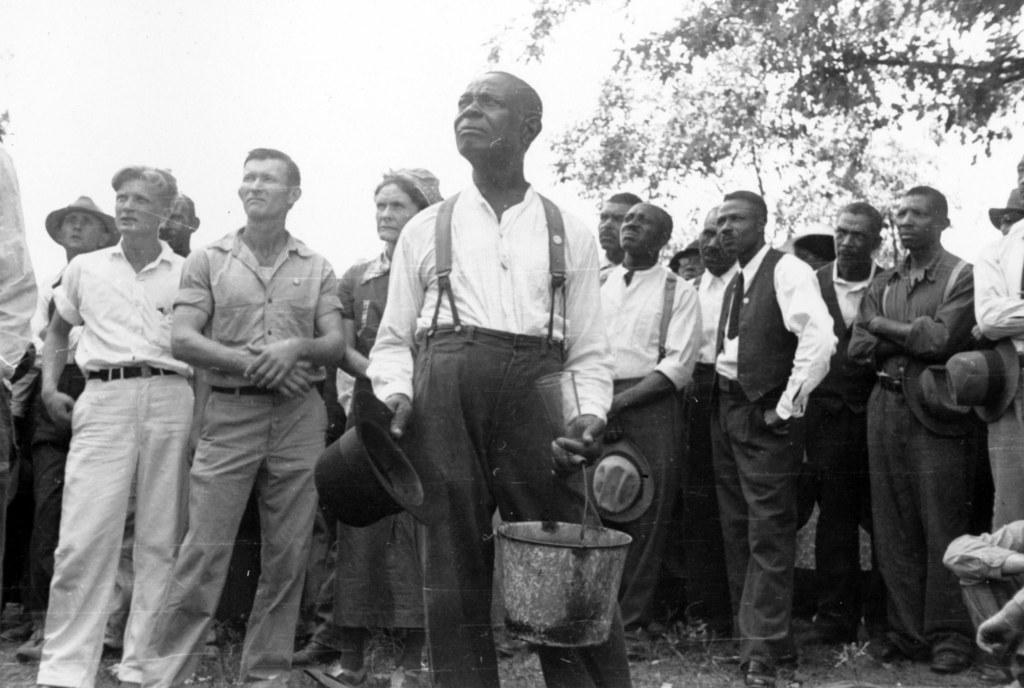What is the color scheme of the image? The image is black and white. What is the man in the image doing? The man is standing and holding a hat and a bucket. Who else is present in the image besides the man? There is a group of people standing in the image. What can be seen in the background of the image? There is a tree in the image. What type of competition is taking place in the image? There is no competition present in the image. How many soldiers are in the army depicted in the image? There is no army or soldiers present in the image. 